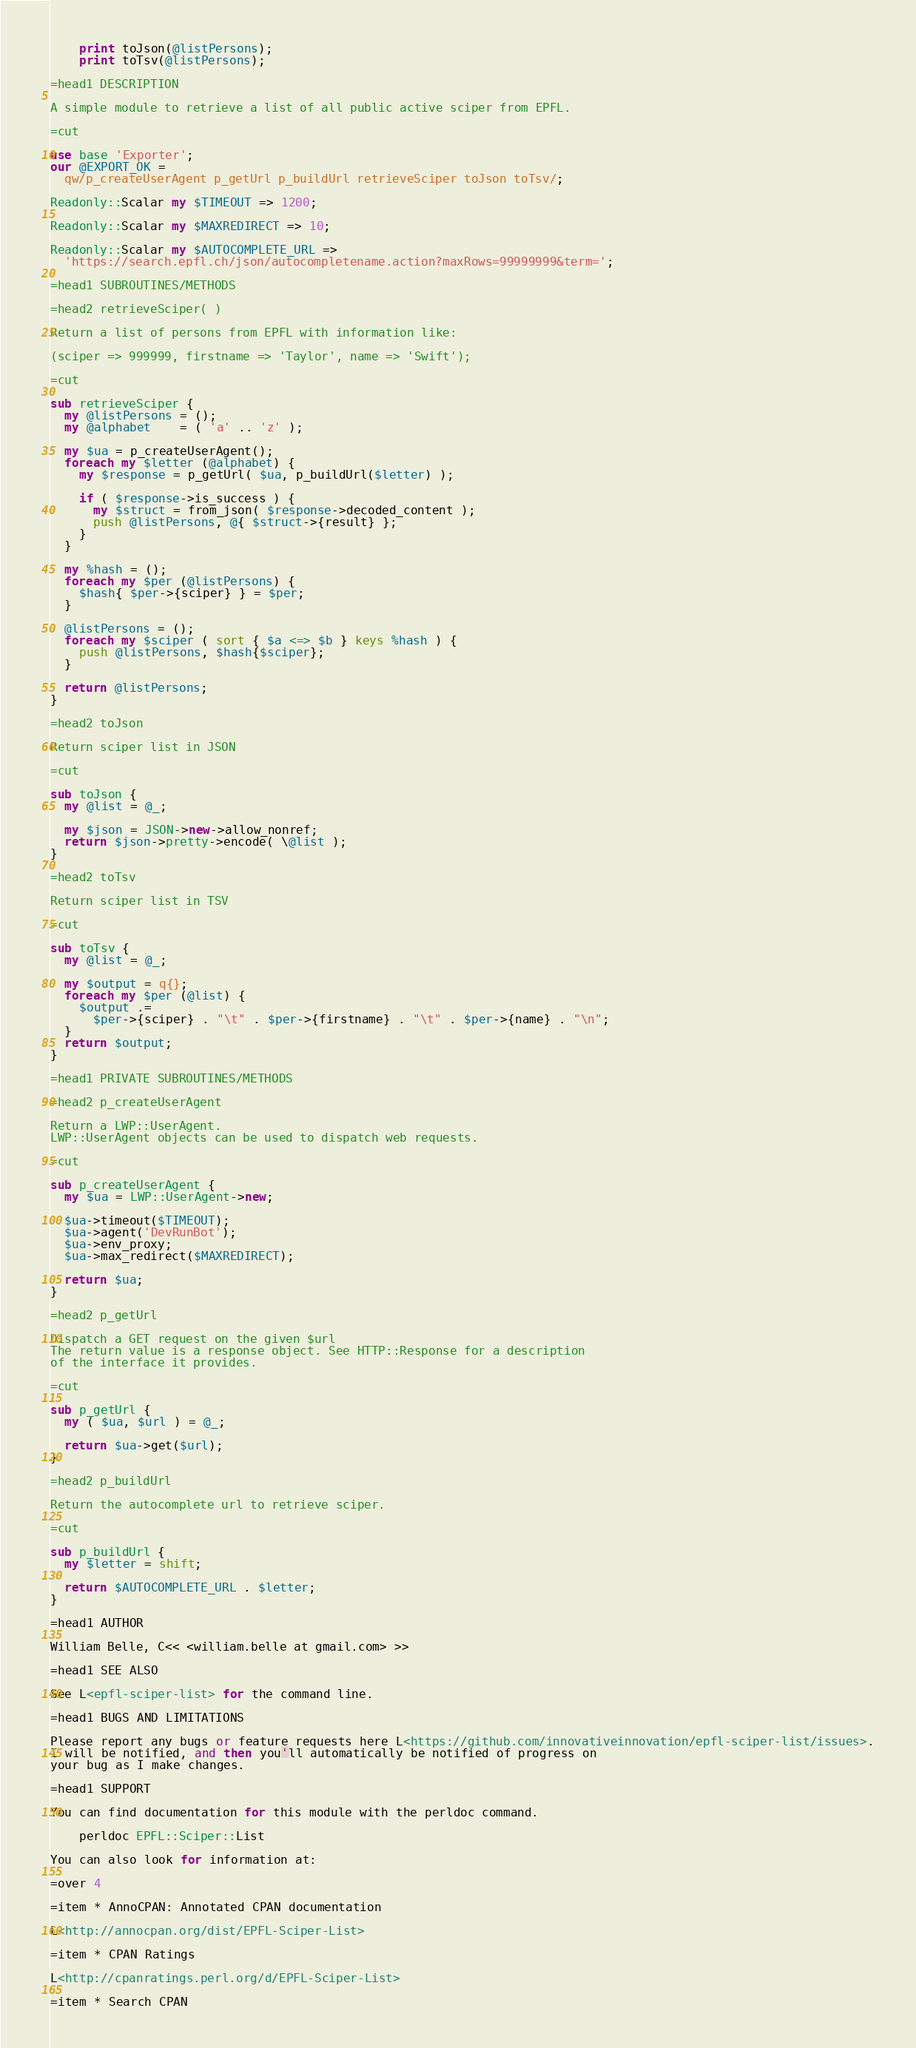<code> <loc_0><loc_0><loc_500><loc_500><_Perl_>    print toJson(@listPersons);
    print toTsv(@listPersons);

=head1 DESCRIPTION

A simple module to retrieve a list of all public active sciper from EPFL.

=cut

use base 'Exporter';
our @EXPORT_OK =
  qw/p_createUserAgent p_getUrl p_buildUrl retrieveSciper toJson toTsv/;

Readonly::Scalar my $TIMEOUT => 1200;

Readonly::Scalar my $MAXREDIRECT => 10;

Readonly::Scalar my $AUTOCOMPLETE_URL =>
  'https://search.epfl.ch/json/autocompletename.action?maxRows=99999999&term=';

=head1 SUBROUTINES/METHODS

=head2 retrieveSciper( )

Return a list of persons from EPFL with information like:

(sciper => 999999, firstname => 'Taylor', name => 'Swift');

=cut

sub retrieveSciper {
  my @listPersons = ();
  my @alphabet    = ( 'a' .. 'z' );

  my $ua = p_createUserAgent();
  foreach my $letter (@alphabet) {
    my $response = p_getUrl( $ua, p_buildUrl($letter) );

    if ( $response->is_success ) {
      my $struct = from_json( $response->decoded_content );
      push @listPersons, @{ $struct->{result} };
    }
  }

  my %hash = ();
  foreach my $per (@listPersons) {
    $hash{ $per->{sciper} } = $per;
  }

  @listPersons = ();
  foreach my $sciper ( sort { $a <=> $b } keys %hash ) {
    push @listPersons, $hash{$sciper};
  }

  return @listPersons;
}

=head2 toJson

Return sciper list in JSON

=cut

sub toJson {
  my @list = @_;

  my $json = JSON->new->allow_nonref;
  return $json->pretty->encode( \@list );
}

=head2 toTsv

Return sciper list in TSV

=cut

sub toTsv {
  my @list = @_;

  my $output = q{};
  foreach my $per (@list) {
    $output .=
      $per->{sciper} . "\t" . $per->{firstname} . "\t" . $per->{name} . "\n";
  }
  return $output;
}

=head1 PRIVATE SUBROUTINES/METHODS

=head2 p_createUserAgent

Return a LWP::UserAgent.
LWP::UserAgent objects can be used to dispatch web requests.

=cut

sub p_createUserAgent {
  my $ua = LWP::UserAgent->new;

  $ua->timeout($TIMEOUT);
  $ua->agent('DevRunBot');
  $ua->env_proxy;
  $ua->max_redirect($MAXREDIRECT);

  return $ua;
}

=head2 p_getUrl

Dispatch a GET request on the given $url
The return value is a response object. See HTTP::Response for a description
of the interface it provides.

=cut

sub p_getUrl {
  my ( $ua, $url ) = @_;

  return $ua->get($url);
}

=head2 p_buildUrl

Return the autocomplete url to retrieve sciper.

=cut

sub p_buildUrl {
  my $letter = shift;

  return $AUTOCOMPLETE_URL . $letter;
}

=head1 AUTHOR

William Belle, C<< <william.belle at gmail.com> >>

=head1 SEE ALSO

See L<epfl-sciper-list> for the command line.

=head1 BUGS AND LIMITATIONS

Please report any bugs or feature requests here L<https://github.com/innovativeinnovation/epfl-sciper-list/issues>.
I will be notified, and then you'll automatically be notified of progress on
your bug as I make changes.

=head1 SUPPORT

You can find documentation for this module with the perldoc command.

    perldoc EPFL::Sciper::List

You can also look for information at:

=over 4

=item * AnnoCPAN: Annotated CPAN documentation

L<http://annocpan.org/dist/EPFL-Sciper-List>

=item * CPAN Ratings

L<http://cpanratings.perl.org/d/EPFL-Sciper-List>

=item * Search CPAN
</code> 